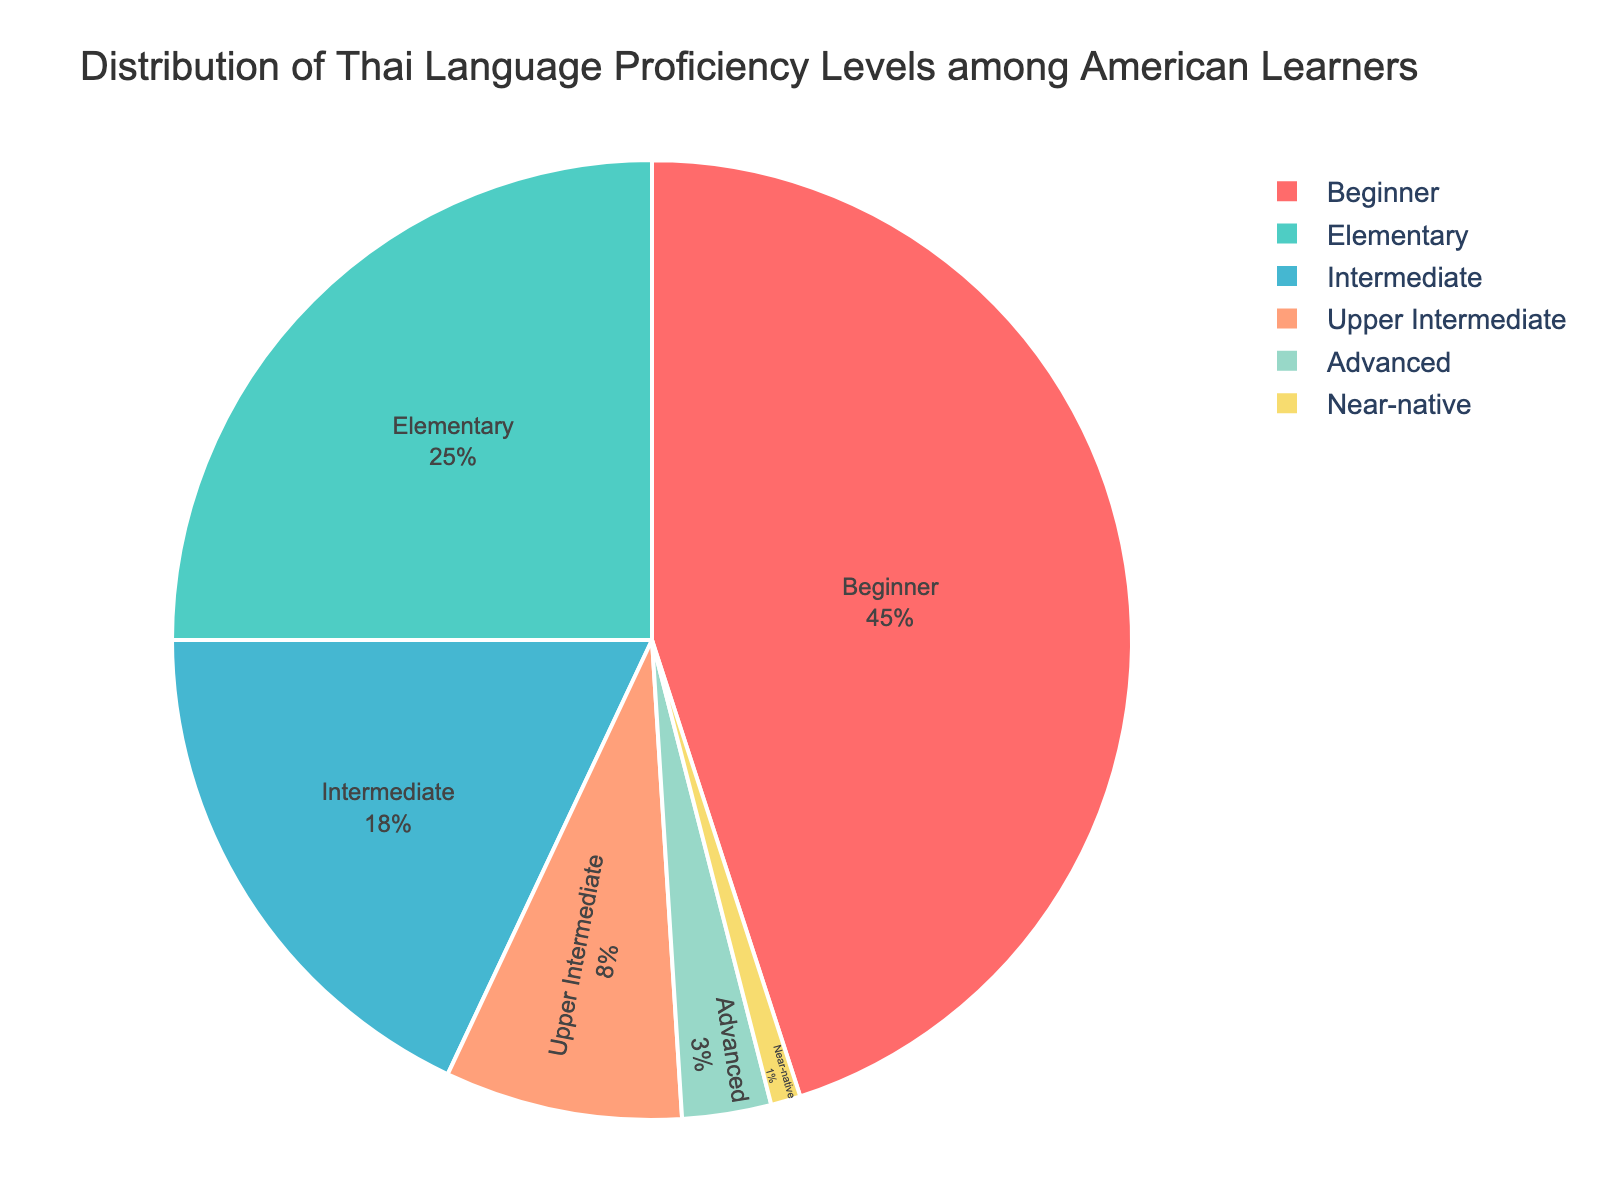Which proficiency level has the highest percentage? The chart shows different slices representing each proficiency level's percentage. The largest slice corresponds to the beginner level.
Answer: Beginner Which two levels together make up the majority of American learners? Add the percentages of the top two levels: Beginner (45%) and Elementary (25%). 45% + 25% = 70%.
Answer: Beginner and Elementary What is the percentage difference between Intermediate and Upper Intermediate levels? The percentage for Intermediate is 18%, and for Upper Intermediate is 8%. The difference is 18% - 8%.
Answer: 10% How much larger is the beginner level compared to the advanced level? Compare the percentages of the Beginner level (45%) and the Advanced level (3%). Calculate the difference: 45% - 3%.
Answer: 42% What percentage of learners are at upper intermediate or higher levels? Sum the percentages for Upper Intermediate (8%), Advanced (3%), and Near-native (1%). 8% + 3% + 1% = 12%.
Answer: 12% Which levels have less than 10% of learners each? Identify slices with percentages less than 10%. These are Upper Intermediate (8%), Advanced (3%), and Near-native (1%).
Answer: Upper Intermediate, Advanced, and Near-native Is the percentage of elementary learners greater than the combined percentage of advanced and near-native learners? Compare Elementary's percentage (25%) with the sum of Advanced (3%) and Near-native (1%): 25% > 3% + 1% = 4%.
Answer: Yes What is the most common proficiency level among American learners? The slice with the largest percentage corresponds to the Beginner level, which is 45%.
Answer: Beginner How many percentage points do elementary learners need to surpass beginners? The percentage for Elementary is 25%, and for Beginner is 45%. The difference is 45% - 25%.
Answer: 20% What's the combined percentage of Intermediate and Elementary levels? Add the percentages for Intermediate (18%) and Elementary (25%). 18% + 25% = 43%.
Answer: 43% 